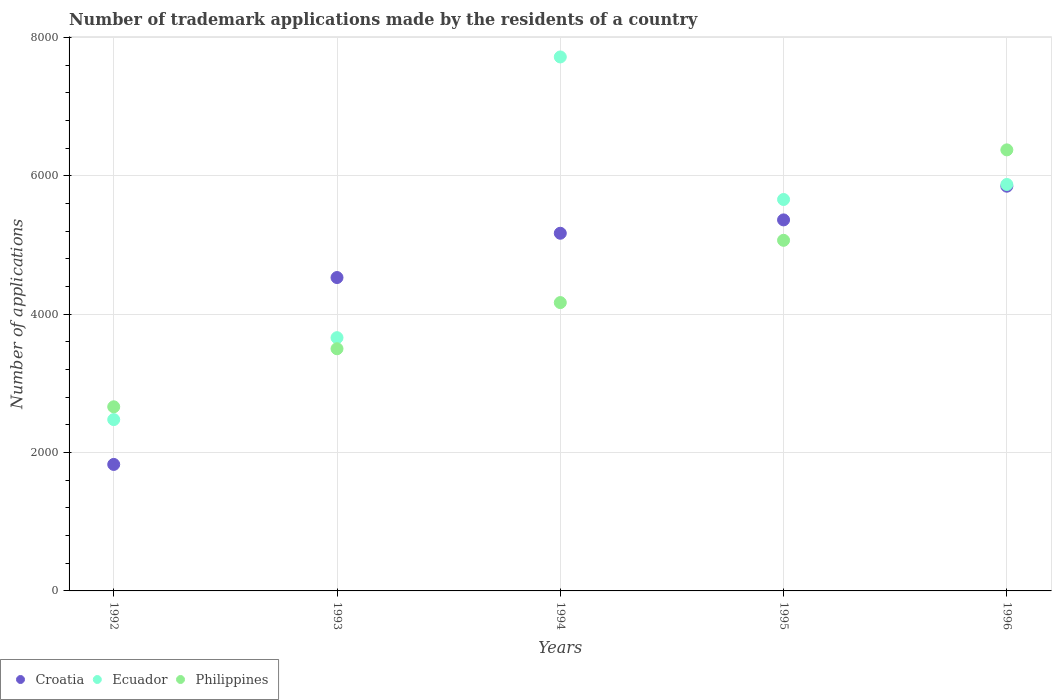Is the number of dotlines equal to the number of legend labels?
Ensure brevity in your answer.  Yes. What is the number of trademark applications made by the residents in Philippines in 1992?
Provide a short and direct response. 2661. Across all years, what is the maximum number of trademark applications made by the residents in Croatia?
Offer a terse response. 5849. Across all years, what is the minimum number of trademark applications made by the residents in Philippines?
Provide a short and direct response. 2661. In which year was the number of trademark applications made by the residents in Philippines maximum?
Provide a succinct answer. 1996. What is the total number of trademark applications made by the residents in Philippines in the graph?
Your answer should be compact. 2.18e+04. What is the difference between the number of trademark applications made by the residents in Philippines in 1993 and that in 1996?
Your answer should be compact. -2874. What is the difference between the number of trademark applications made by the residents in Ecuador in 1992 and the number of trademark applications made by the residents in Croatia in 1994?
Make the answer very short. -2693. What is the average number of trademark applications made by the residents in Croatia per year?
Keep it short and to the point. 4547.4. In the year 1992, what is the difference between the number of trademark applications made by the residents in Philippines and number of trademark applications made by the residents in Croatia?
Your response must be concise. 833. In how many years, is the number of trademark applications made by the residents in Philippines greater than 3600?
Ensure brevity in your answer.  3. What is the ratio of the number of trademark applications made by the residents in Ecuador in 1993 to that in 1995?
Your answer should be very brief. 0.65. Is the number of trademark applications made by the residents in Philippines in 1994 less than that in 1995?
Ensure brevity in your answer.  Yes. What is the difference between the highest and the second highest number of trademark applications made by the residents in Ecuador?
Ensure brevity in your answer.  1843. What is the difference between the highest and the lowest number of trademark applications made by the residents in Philippines?
Your answer should be very brief. 3713. In how many years, is the number of trademark applications made by the residents in Ecuador greater than the average number of trademark applications made by the residents in Ecuador taken over all years?
Offer a very short reply. 3. Is the sum of the number of trademark applications made by the residents in Ecuador in 1993 and 1996 greater than the maximum number of trademark applications made by the residents in Philippines across all years?
Your answer should be compact. Yes. Is it the case that in every year, the sum of the number of trademark applications made by the residents in Croatia and number of trademark applications made by the residents in Philippines  is greater than the number of trademark applications made by the residents in Ecuador?
Ensure brevity in your answer.  Yes. Is the number of trademark applications made by the residents in Croatia strictly greater than the number of trademark applications made by the residents in Philippines over the years?
Your answer should be very brief. No. What is the difference between two consecutive major ticks on the Y-axis?
Keep it short and to the point. 2000. Are the values on the major ticks of Y-axis written in scientific E-notation?
Your answer should be compact. No. Does the graph contain grids?
Make the answer very short. Yes. How many legend labels are there?
Your response must be concise. 3. How are the legend labels stacked?
Your answer should be compact. Horizontal. What is the title of the graph?
Provide a succinct answer. Number of trademark applications made by the residents of a country. What is the label or title of the Y-axis?
Make the answer very short. Number of applications. What is the Number of applications of Croatia in 1992?
Offer a terse response. 1828. What is the Number of applications of Ecuador in 1992?
Ensure brevity in your answer.  2476. What is the Number of applications in Philippines in 1992?
Ensure brevity in your answer.  2661. What is the Number of applications in Croatia in 1993?
Make the answer very short. 4529. What is the Number of applications in Ecuador in 1993?
Give a very brief answer. 3660. What is the Number of applications in Philippines in 1993?
Give a very brief answer. 3500. What is the Number of applications of Croatia in 1994?
Offer a very short reply. 5169. What is the Number of applications of Ecuador in 1994?
Keep it short and to the point. 7717. What is the Number of applications in Philippines in 1994?
Give a very brief answer. 4167. What is the Number of applications in Croatia in 1995?
Your answer should be very brief. 5362. What is the Number of applications of Ecuador in 1995?
Provide a short and direct response. 5657. What is the Number of applications in Philippines in 1995?
Make the answer very short. 5067. What is the Number of applications in Croatia in 1996?
Ensure brevity in your answer.  5849. What is the Number of applications in Ecuador in 1996?
Offer a terse response. 5874. What is the Number of applications of Philippines in 1996?
Your answer should be very brief. 6374. Across all years, what is the maximum Number of applications of Croatia?
Make the answer very short. 5849. Across all years, what is the maximum Number of applications of Ecuador?
Ensure brevity in your answer.  7717. Across all years, what is the maximum Number of applications of Philippines?
Give a very brief answer. 6374. Across all years, what is the minimum Number of applications of Croatia?
Your response must be concise. 1828. Across all years, what is the minimum Number of applications in Ecuador?
Provide a succinct answer. 2476. Across all years, what is the minimum Number of applications in Philippines?
Keep it short and to the point. 2661. What is the total Number of applications of Croatia in the graph?
Your answer should be compact. 2.27e+04. What is the total Number of applications in Ecuador in the graph?
Your response must be concise. 2.54e+04. What is the total Number of applications in Philippines in the graph?
Your response must be concise. 2.18e+04. What is the difference between the Number of applications of Croatia in 1992 and that in 1993?
Provide a short and direct response. -2701. What is the difference between the Number of applications in Ecuador in 1992 and that in 1993?
Keep it short and to the point. -1184. What is the difference between the Number of applications in Philippines in 1992 and that in 1993?
Your response must be concise. -839. What is the difference between the Number of applications of Croatia in 1992 and that in 1994?
Your response must be concise. -3341. What is the difference between the Number of applications in Ecuador in 1992 and that in 1994?
Make the answer very short. -5241. What is the difference between the Number of applications of Philippines in 1992 and that in 1994?
Make the answer very short. -1506. What is the difference between the Number of applications of Croatia in 1992 and that in 1995?
Provide a succinct answer. -3534. What is the difference between the Number of applications in Ecuador in 1992 and that in 1995?
Ensure brevity in your answer.  -3181. What is the difference between the Number of applications in Philippines in 1992 and that in 1995?
Provide a succinct answer. -2406. What is the difference between the Number of applications in Croatia in 1992 and that in 1996?
Provide a short and direct response. -4021. What is the difference between the Number of applications of Ecuador in 1992 and that in 1996?
Keep it short and to the point. -3398. What is the difference between the Number of applications in Philippines in 1992 and that in 1996?
Make the answer very short. -3713. What is the difference between the Number of applications of Croatia in 1993 and that in 1994?
Provide a short and direct response. -640. What is the difference between the Number of applications in Ecuador in 1993 and that in 1994?
Offer a terse response. -4057. What is the difference between the Number of applications of Philippines in 1993 and that in 1994?
Offer a very short reply. -667. What is the difference between the Number of applications of Croatia in 1993 and that in 1995?
Your answer should be very brief. -833. What is the difference between the Number of applications of Ecuador in 1993 and that in 1995?
Keep it short and to the point. -1997. What is the difference between the Number of applications in Philippines in 1993 and that in 1995?
Your answer should be compact. -1567. What is the difference between the Number of applications of Croatia in 1993 and that in 1996?
Give a very brief answer. -1320. What is the difference between the Number of applications of Ecuador in 1993 and that in 1996?
Offer a very short reply. -2214. What is the difference between the Number of applications in Philippines in 1993 and that in 1996?
Provide a short and direct response. -2874. What is the difference between the Number of applications in Croatia in 1994 and that in 1995?
Provide a succinct answer. -193. What is the difference between the Number of applications in Ecuador in 1994 and that in 1995?
Keep it short and to the point. 2060. What is the difference between the Number of applications in Philippines in 1994 and that in 1995?
Keep it short and to the point. -900. What is the difference between the Number of applications of Croatia in 1994 and that in 1996?
Provide a short and direct response. -680. What is the difference between the Number of applications in Ecuador in 1994 and that in 1996?
Your response must be concise. 1843. What is the difference between the Number of applications in Philippines in 1994 and that in 1996?
Ensure brevity in your answer.  -2207. What is the difference between the Number of applications in Croatia in 1995 and that in 1996?
Your answer should be compact. -487. What is the difference between the Number of applications in Ecuador in 1995 and that in 1996?
Your answer should be very brief. -217. What is the difference between the Number of applications in Philippines in 1995 and that in 1996?
Provide a succinct answer. -1307. What is the difference between the Number of applications in Croatia in 1992 and the Number of applications in Ecuador in 1993?
Ensure brevity in your answer.  -1832. What is the difference between the Number of applications in Croatia in 1992 and the Number of applications in Philippines in 1993?
Make the answer very short. -1672. What is the difference between the Number of applications in Ecuador in 1992 and the Number of applications in Philippines in 1993?
Make the answer very short. -1024. What is the difference between the Number of applications of Croatia in 1992 and the Number of applications of Ecuador in 1994?
Provide a succinct answer. -5889. What is the difference between the Number of applications in Croatia in 1992 and the Number of applications in Philippines in 1994?
Your response must be concise. -2339. What is the difference between the Number of applications of Ecuador in 1992 and the Number of applications of Philippines in 1994?
Offer a terse response. -1691. What is the difference between the Number of applications of Croatia in 1992 and the Number of applications of Ecuador in 1995?
Your answer should be very brief. -3829. What is the difference between the Number of applications of Croatia in 1992 and the Number of applications of Philippines in 1995?
Ensure brevity in your answer.  -3239. What is the difference between the Number of applications in Ecuador in 1992 and the Number of applications in Philippines in 1995?
Ensure brevity in your answer.  -2591. What is the difference between the Number of applications of Croatia in 1992 and the Number of applications of Ecuador in 1996?
Offer a terse response. -4046. What is the difference between the Number of applications in Croatia in 1992 and the Number of applications in Philippines in 1996?
Offer a very short reply. -4546. What is the difference between the Number of applications of Ecuador in 1992 and the Number of applications of Philippines in 1996?
Make the answer very short. -3898. What is the difference between the Number of applications of Croatia in 1993 and the Number of applications of Ecuador in 1994?
Your answer should be very brief. -3188. What is the difference between the Number of applications of Croatia in 1993 and the Number of applications of Philippines in 1994?
Your response must be concise. 362. What is the difference between the Number of applications of Ecuador in 1993 and the Number of applications of Philippines in 1994?
Make the answer very short. -507. What is the difference between the Number of applications of Croatia in 1993 and the Number of applications of Ecuador in 1995?
Offer a very short reply. -1128. What is the difference between the Number of applications of Croatia in 1993 and the Number of applications of Philippines in 1995?
Provide a succinct answer. -538. What is the difference between the Number of applications of Ecuador in 1993 and the Number of applications of Philippines in 1995?
Provide a short and direct response. -1407. What is the difference between the Number of applications of Croatia in 1993 and the Number of applications of Ecuador in 1996?
Your response must be concise. -1345. What is the difference between the Number of applications of Croatia in 1993 and the Number of applications of Philippines in 1996?
Give a very brief answer. -1845. What is the difference between the Number of applications in Ecuador in 1993 and the Number of applications in Philippines in 1996?
Your answer should be very brief. -2714. What is the difference between the Number of applications of Croatia in 1994 and the Number of applications of Ecuador in 1995?
Offer a very short reply. -488. What is the difference between the Number of applications of Croatia in 1994 and the Number of applications of Philippines in 1995?
Offer a terse response. 102. What is the difference between the Number of applications of Ecuador in 1994 and the Number of applications of Philippines in 1995?
Offer a terse response. 2650. What is the difference between the Number of applications of Croatia in 1994 and the Number of applications of Ecuador in 1996?
Your response must be concise. -705. What is the difference between the Number of applications of Croatia in 1994 and the Number of applications of Philippines in 1996?
Offer a very short reply. -1205. What is the difference between the Number of applications of Ecuador in 1994 and the Number of applications of Philippines in 1996?
Your answer should be compact. 1343. What is the difference between the Number of applications in Croatia in 1995 and the Number of applications in Ecuador in 1996?
Offer a very short reply. -512. What is the difference between the Number of applications of Croatia in 1995 and the Number of applications of Philippines in 1996?
Keep it short and to the point. -1012. What is the difference between the Number of applications of Ecuador in 1995 and the Number of applications of Philippines in 1996?
Your response must be concise. -717. What is the average Number of applications in Croatia per year?
Provide a succinct answer. 4547.4. What is the average Number of applications of Ecuador per year?
Ensure brevity in your answer.  5076.8. What is the average Number of applications of Philippines per year?
Your answer should be very brief. 4353.8. In the year 1992, what is the difference between the Number of applications in Croatia and Number of applications in Ecuador?
Keep it short and to the point. -648. In the year 1992, what is the difference between the Number of applications of Croatia and Number of applications of Philippines?
Give a very brief answer. -833. In the year 1992, what is the difference between the Number of applications in Ecuador and Number of applications in Philippines?
Offer a very short reply. -185. In the year 1993, what is the difference between the Number of applications in Croatia and Number of applications in Ecuador?
Give a very brief answer. 869. In the year 1993, what is the difference between the Number of applications of Croatia and Number of applications of Philippines?
Give a very brief answer. 1029. In the year 1993, what is the difference between the Number of applications of Ecuador and Number of applications of Philippines?
Keep it short and to the point. 160. In the year 1994, what is the difference between the Number of applications of Croatia and Number of applications of Ecuador?
Offer a very short reply. -2548. In the year 1994, what is the difference between the Number of applications of Croatia and Number of applications of Philippines?
Offer a very short reply. 1002. In the year 1994, what is the difference between the Number of applications in Ecuador and Number of applications in Philippines?
Provide a short and direct response. 3550. In the year 1995, what is the difference between the Number of applications of Croatia and Number of applications of Ecuador?
Offer a terse response. -295. In the year 1995, what is the difference between the Number of applications of Croatia and Number of applications of Philippines?
Provide a succinct answer. 295. In the year 1995, what is the difference between the Number of applications of Ecuador and Number of applications of Philippines?
Keep it short and to the point. 590. In the year 1996, what is the difference between the Number of applications of Croatia and Number of applications of Ecuador?
Ensure brevity in your answer.  -25. In the year 1996, what is the difference between the Number of applications in Croatia and Number of applications in Philippines?
Offer a terse response. -525. In the year 1996, what is the difference between the Number of applications of Ecuador and Number of applications of Philippines?
Keep it short and to the point. -500. What is the ratio of the Number of applications of Croatia in 1992 to that in 1993?
Your answer should be very brief. 0.4. What is the ratio of the Number of applications of Ecuador in 1992 to that in 1993?
Ensure brevity in your answer.  0.68. What is the ratio of the Number of applications of Philippines in 1992 to that in 1993?
Your answer should be compact. 0.76. What is the ratio of the Number of applications in Croatia in 1992 to that in 1994?
Provide a short and direct response. 0.35. What is the ratio of the Number of applications of Ecuador in 1992 to that in 1994?
Ensure brevity in your answer.  0.32. What is the ratio of the Number of applications in Philippines in 1992 to that in 1994?
Make the answer very short. 0.64. What is the ratio of the Number of applications of Croatia in 1992 to that in 1995?
Offer a terse response. 0.34. What is the ratio of the Number of applications in Ecuador in 1992 to that in 1995?
Provide a short and direct response. 0.44. What is the ratio of the Number of applications in Philippines in 1992 to that in 1995?
Make the answer very short. 0.53. What is the ratio of the Number of applications in Croatia in 1992 to that in 1996?
Ensure brevity in your answer.  0.31. What is the ratio of the Number of applications of Ecuador in 1992 to that in 1996?
Provide a succinct answer. 0.42. What is the ratio of the Number of applications in Philippines in 1992 to that in 1996?
Your answer should be very brief. 0.42. What is the ratio of the Number of applications of Croatia in 1993 to that in 1994?
Offer a terse response. 0.88. What is the ratio of the Number of applications of Ecuador in 1993 to that in 1994?
Your answer should be very brief. 0.47. What is the ratio of the Number of applications in Philippines in 1993 to that in 1994?
Your response must be concise. 0.84. What is the ratio of the Number of applications in Croatia in 1993 to that in 1995?
Keep it short and to the point. 0.84. What is the ratio of the Number of applications in Ecuador in 1993 to that in 1995?
Provide a succinct answer. 0.65. What is the ratio of the Number of applications in Philippines in 1993 to that in 1995?
Give a very brief answer. 0.69. What is the ratio of the Number of applications of Croatia in 1993 to that in 1996?
Ensure brevity in your answer.  0.77. What is the ratio of the Number of applications in Ecuador in 1993 to that in 1996?
Make the answer very short. 0.62. What is the ratio of the Number of applications in Philippines in 1993 to that in 1996?
Your answer should be very brief. 0.55. What is the ratio of the Number of applications of Croatia in 1994 to that in 1995?
Keep it short and to the point. 0.96. What is the ratio of the Number of applications of Ecuador in 1994 to that in 1995?
Provide a succinct answer. 1.36. What is the ratio of the Number of applications of Philippines in 1994 to that in 1995?
Offer a terse response. 0.82. What is the ratio of the Number of applications in Croatia in 1994 to that in 1996?
Your response must be concise. 0.88. What is the ratio of the Number of applications of Ecuador in 1994 to that in 1996?
Offer a terse response. 1.31. What is the ratio of the Number of applications of Philippines in 1994 to that in 1996?
Offer a very short reply. 0.65. What is the ratio of the Number of applications of Croatia in 1995 to that in 1996?
Keep it short and to the point. 0.92. What is the ratio of the Number of applications in Ecuador in 1995 to that in 1996?
Your response must be concise. 0.96. What is the ratio of the Number of applications of Philippines in 1995 to that in 1996?
Offer a very short reply. 0.79. What is the difference between the highest and the second highest Number of applications of Croatia?
Provide a short and direct response. 487. What is the difference between the highest and the second highest Number of applications of Ecuador?
Your response must be concise. 1843. What is the difference between the highest and the second highest Number of applications in Philippines?
Keep it short and to the point. 1307. What is the difference between the highest and the lowest Number of applications of Croatia?
Give a very brief answer. 4021. What is the difference between the highest and the lowest Number of applications in Ecuador?
Give a very brief answer. 5241. What is the difference between the highest and the lowest Number of applications in Philippines?
Your answer should be compact. 3713. 